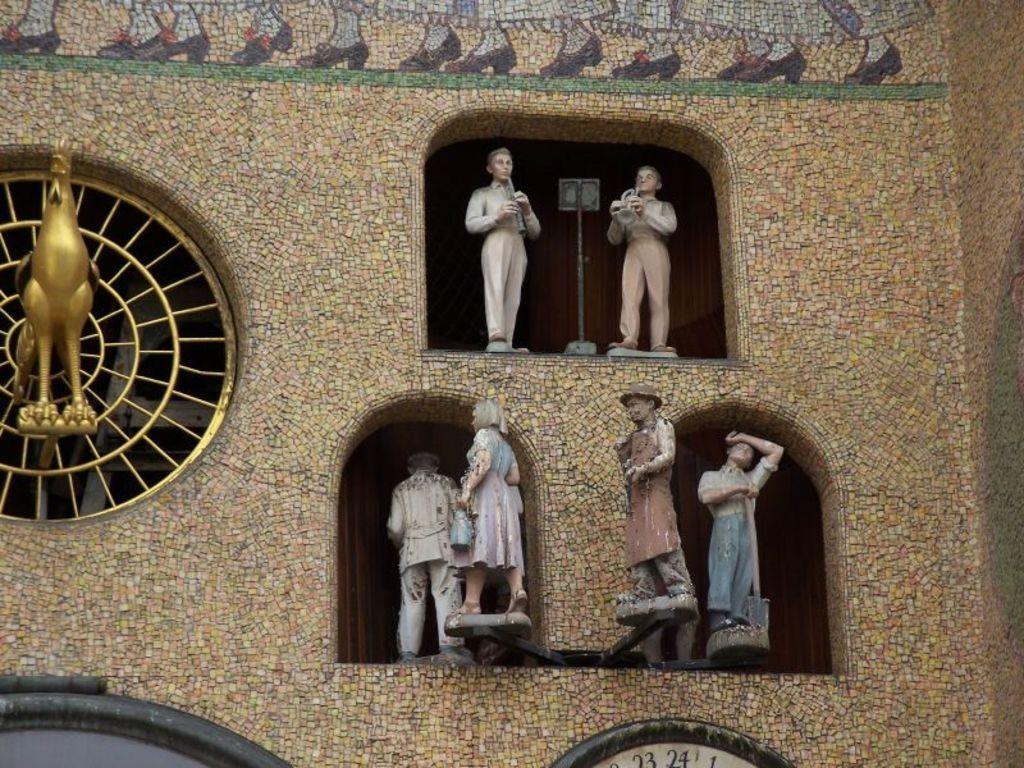What type of artwork can be seen on the wall in the image? There are sculptures on the wall in the image. Can you describe any other objects present in the image? Unfortunately, the provided facts do not give any information about other objects in the image. How many dimes are hidden inside the sock in the image? There is no mention of dimes or socks in the provided facts, so we cannot answer this question. 